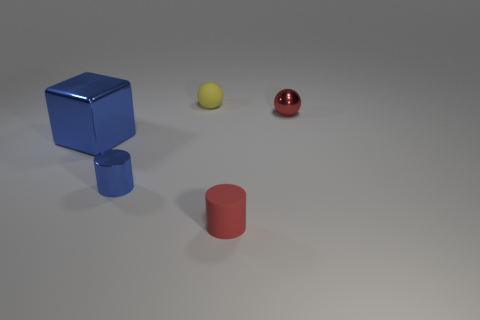The other thing that is the same shape as the tiny blue thing is what size?
Give a very brief answer. Small. There is a tiny cylinder that is the same color as the metal cube; what is it made of?
Your response must be concise. Metal. How many tiny objects have the same color as the big block?
Your response must be concise. 1. What size is the cylinder that is the same material as the large blue object?
Your response must be concise. Small. What color is the cylinder that is made of the same material as the small red sphere?
Provide a succinct answer. Blue. Are there any brown rubber cylinders of the same size as the blue shiny cylinder?
Your answer should be very brief. No. There is a small red object that is the same shape as the yellow rubber object; what is its material?
Your answer should be very brief. Metal. The blue thing that is the same size as the matte cylinder is what shape?
Your answer should be compact. Cylinder. Is there a big brown metallic thing that has the same shape as the large blue metallic thing?
Provide a short and direct response. No. What shape is the rubber thing that is on the right side of the thing behind the metal sphere?
Give a very brief answer. Cylinder. 